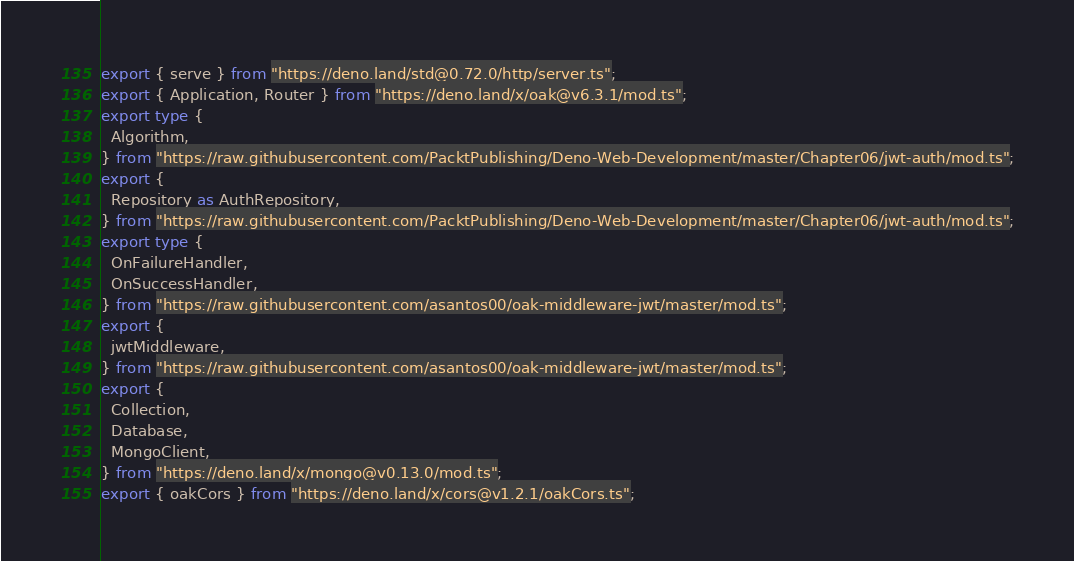<code> <loc_0><loc_0><loc_500><loc_500><_TypeScript_>export { serve } from "https://deno.land/std@0.72.0/http/server.ts";
export { Application, Router } from "https://deno.land/x/oak@v6.3.1/mod.ts";
export type {
  Algorithm,
} from "https://raw.githubusercontent.com/PacktPublishing/Deno-Web-Development/master/Chapter06/jwt-auth/mod.ts";
export {
  Repository as AuthRepository,
} from "https://raw.githubusercontent.com/PacktPublishing/Deno-Web-Development/master/Chapter06/jwt-auth/mod.ts";
export type {
  OnFailureHandler,
  OnSuccessHandler,
} from "https://raw.githubusercontent.com/asantos00/oak-middleware-jwt/master/mod.ts";
export {
  jwtMiddleware,
} from "https://raw.githubusercontent.com/asantos00/oak-middleware-jwt/master/mod.ts";
export {
  Collection,
  Database,
  MongoClient,
} from "https://deno.land/x/mongo@v0.13.0/mod.ts";
export { oakCors } from "https://deno.land/x/cors@v1.2.1/oakCors.ts";
</code> 